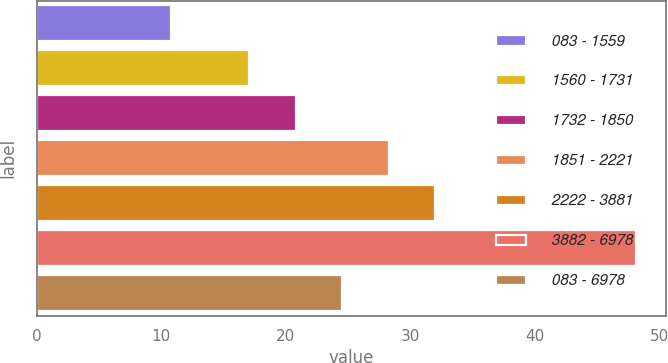Convert chart to OTSL. <chart><loc_0><loc_0><loc_500><loc_500><bar_chart><fcel>083 - 1559<fcel>1560 - 1731<fcel>1732 - 1850<fcel>1851 - 2221<fcel>2222 - 3881<fcel>3882 - 6978<fcel>083 - 6978<nl><fcel>10.83<fcel>17.07<fcel>20.8<fcel>28.26<fcel>31.99<fcel>48.11<fcel>24.53<nl></chart> 